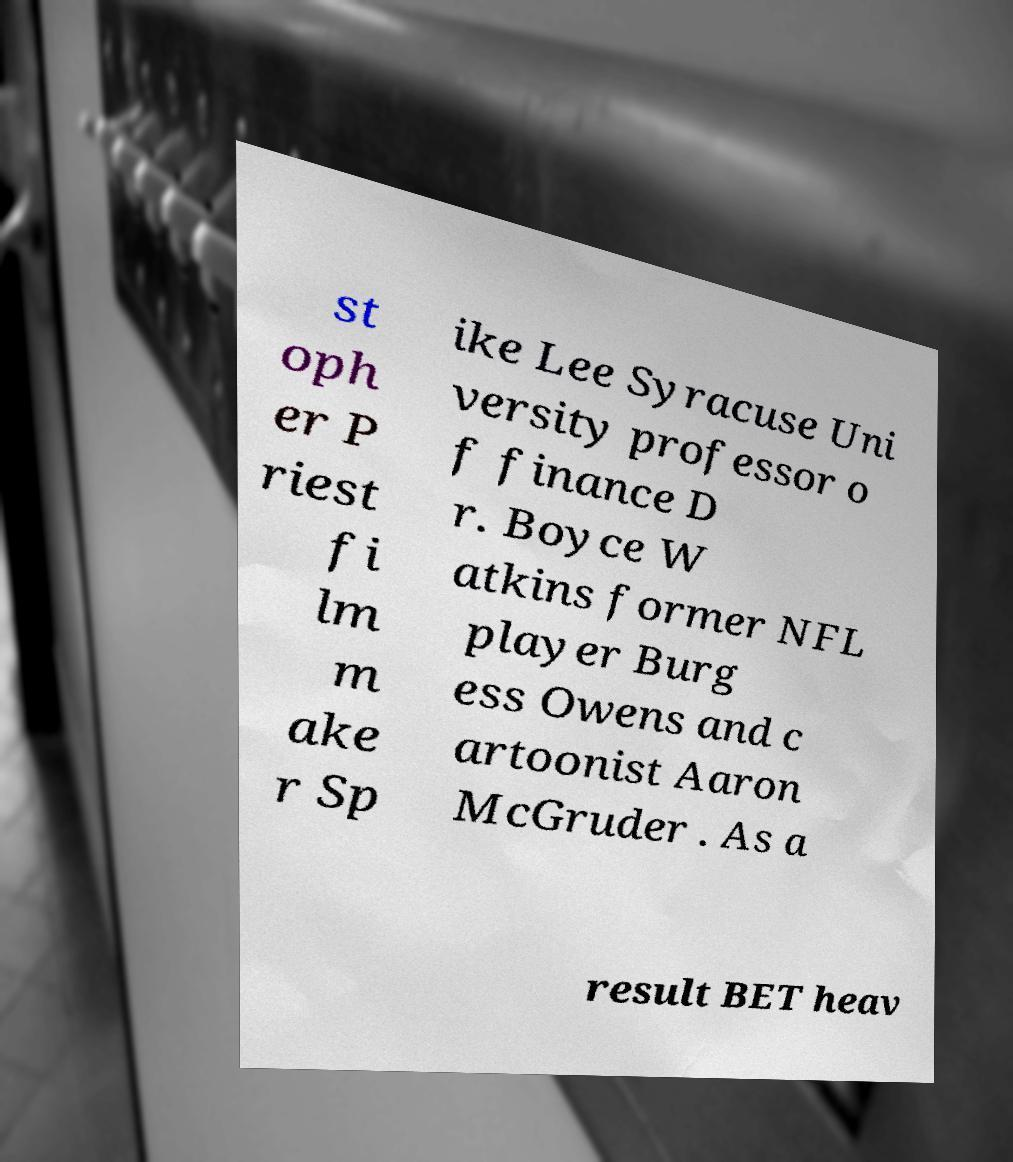Can you read and provide the text displayed in the image?This photo seems to have some interesting text. Can you extract and type it out for me? st oph er P riest fi lm m ake r Sp ike Lee Syracuse Uni versity professor o f finance D r. Boyce W atkins former NFL player Burg ess Owens and c artoonist Aaron McGruder . As a result BET heav 